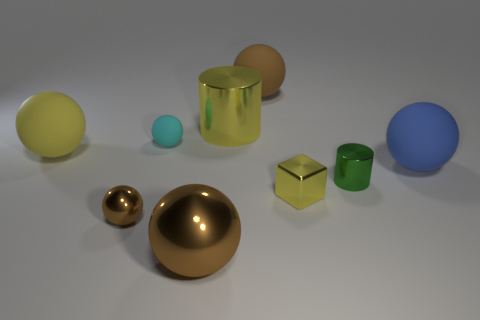There is a large rubber thing that is right of the cyan rubber ball and on the left side of the green metal thing; what is its shape?
Your response must be concise. Sphere. What number of large objects are yellow rubber balls or rubber things?
Offer a very short reply. 3. Are there an equal number of objects that are left of the yellow cylinder and tiny metal cylinders that are left of the large brown rubber ball?
Give a very brief answer. No. What number of other objects are there of the same color as the large shiny cylinder?
Your answer should be very brief. 2. Are there an equal number of big yellow cylinders that are on the left side of the tiny metal ball and small metallic cylinders?
Your response must be concise. No. Do the green object and the blue thing have the same size?
Make the answer very short. No. There is a sphere that is behind the yellow matte object and to the left of the big yellow metallic cylinder; what material is it made of?
Keep it short and to the point. Rubber. What number of other metallic things have the same shape as the big yellow metal object?
Your answer should be very brief. 1. What is the yellow thing in front of the big blue matte sphere made of?
Your answer should be very brief. Metal. Are there fewer objects behind the large shiny cylinder than small cyan balls?
Keep it short and to the point. No. 